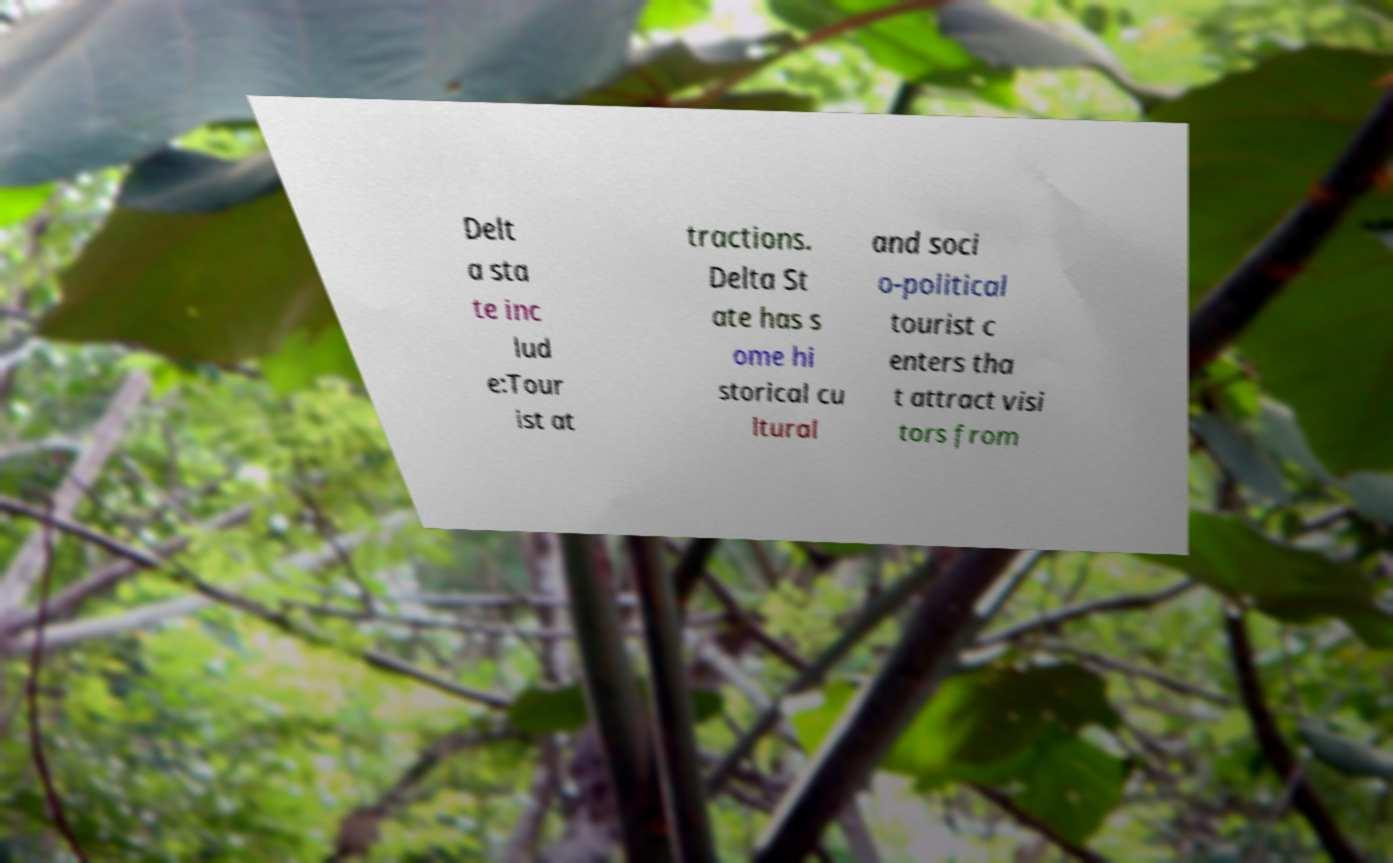For documentation purposes, I need the text within this image transcribed. Could you provide that? Delt a sta te inc lud e:Tour ist at tractions. Delta St ate has s ome hi storical cu ltural and soci o-political tourist c enters tha t attract visi tors from 